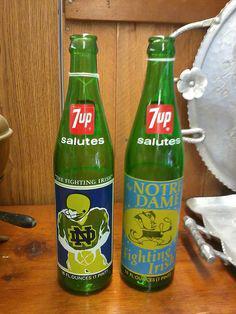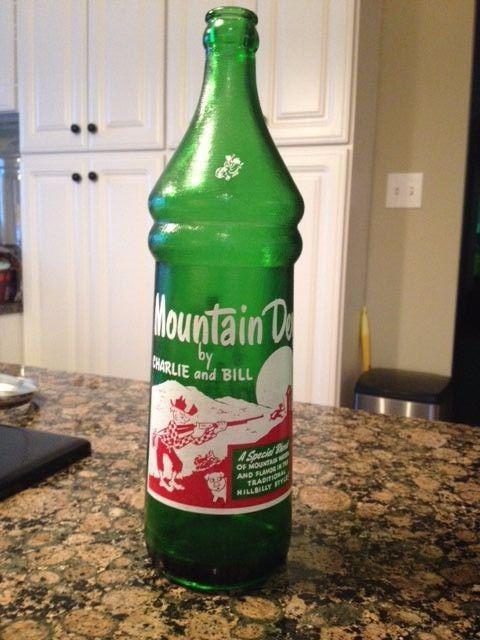The first image is the image on the left, the second image is the image on the right. Analyze the images presented: Is the assertion "An equal number of soda bottles are in each image, all the same brand, but with different labeling in view." valid? Answer yes or no. No. The first image is the image on the left, the second image is the image on the right. Analyze the images presented: Is the assertion "None of the bottles are capped." valid? Answer yes or no. Yes. 